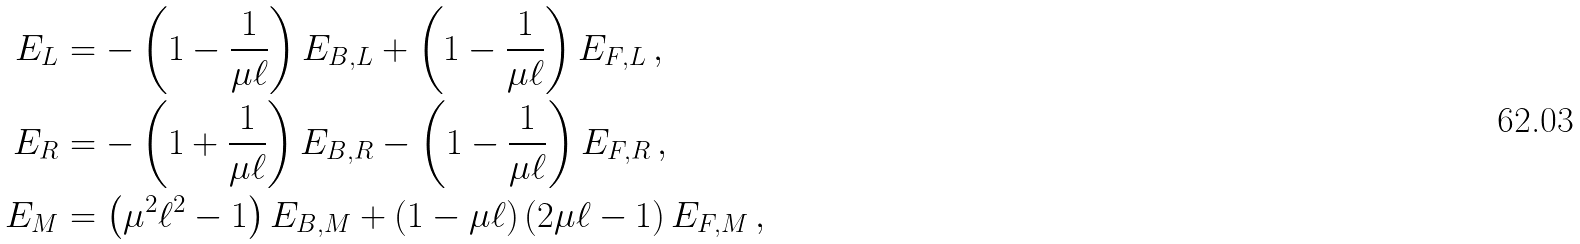<formula> <loc_0><loc_0><loc_500><loc_500>E _ { L } & = - \left ( 1 - \frac { 1 } { \mu \ell } \right ) E _ { B , L } + \left ( 1 - \frac { 1 } { \mu \ell } \right ) E _ { F , L } \, , \\ E _ { R } & = - \left ( 1 + \frac { 1 } { \mu \ell } \right ) E _ { B , R } - \left ( 1 - \frac { 1 } { \mu \ell } \right ) E _ { F , R } \, , \\ E _ { M } & = \left ( \mu ^ { 2 } \ell ^ { 2 } - 1 \right ) E _ { B , M } + \left ( 1 - \mu \ell \right ) \left ( 2 \mu \ell - 1 \right ) E _ { F , M } \, ,</formula> 